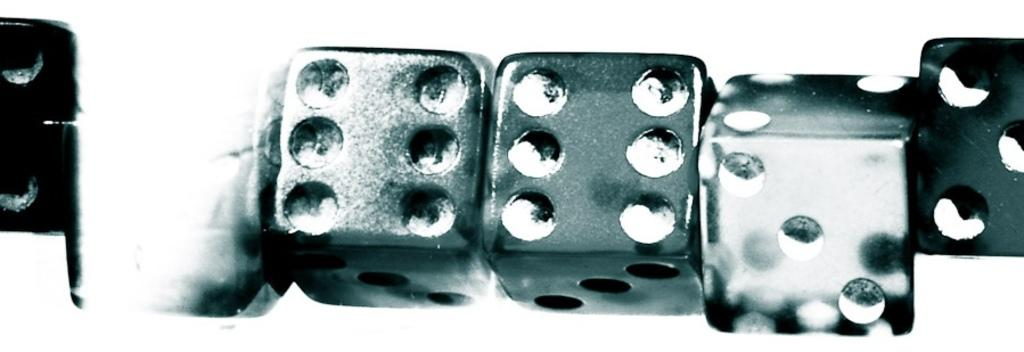What objects are present in the image? There are dices in the image. What might be the purpose of these objects? The dices are likely used for games or entertainment. Can you describe the appearance of the dices? The dices have multiple sides with numbers or symbols on them. Are there any pins visible in the image? There is no mention of pins in the provided fact, so we cannot determine if any are present in the image. 